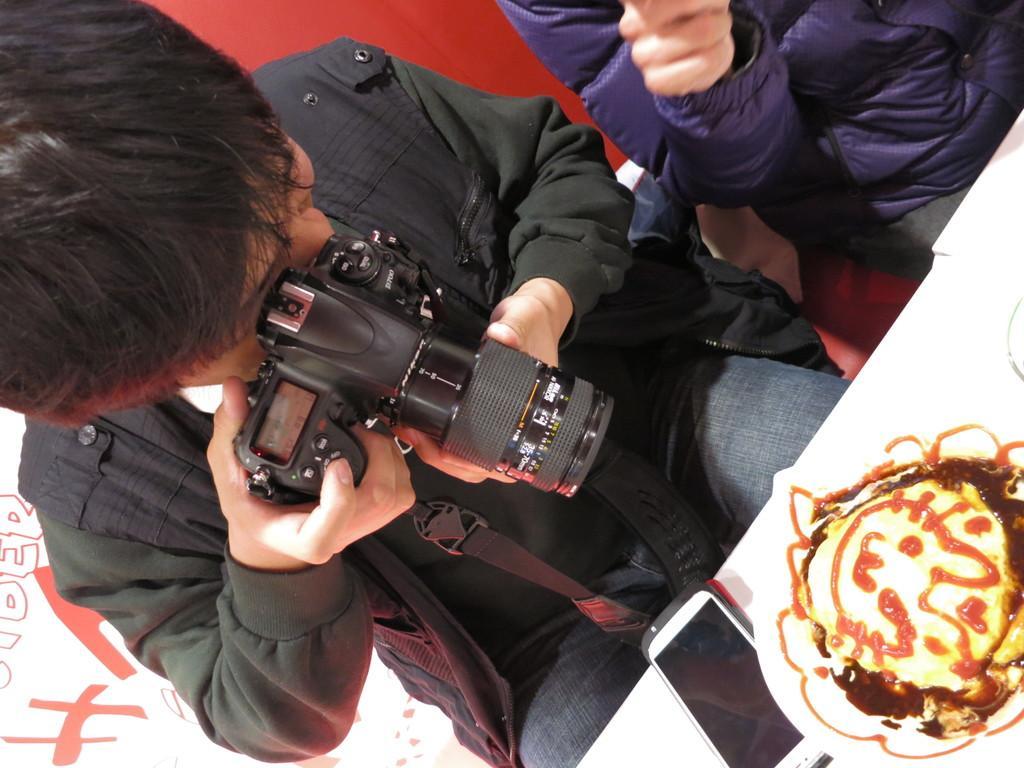How would you summarize this image in a sentence or two? In this image the person is taking a picture. he is holding a camera. He is wearing a jacket and jeans. Beside him one person wearing purple jacket. There is food on the table which is in front of the person. On the table there is phone. It is looking like the man is clicking picture of the food. 